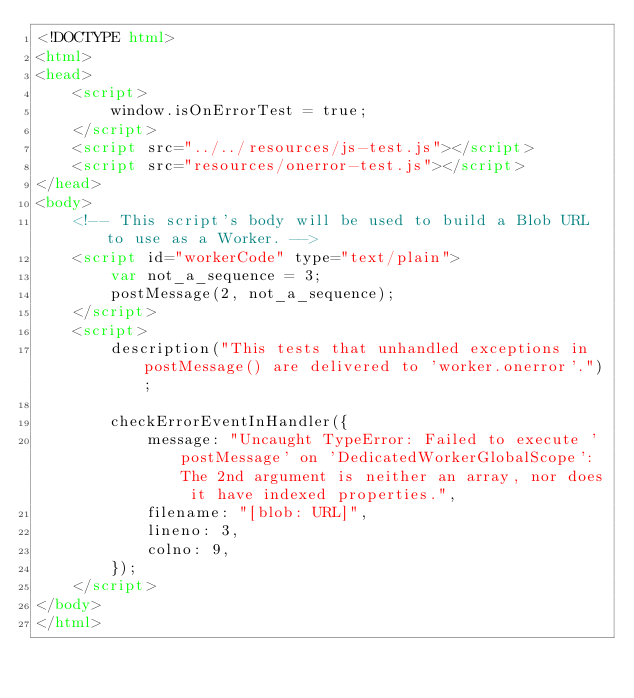Convert code to text. <code><loc_0><loc_0><loc_500><loc_500><_HTML_><!DOCTYPE html>
<html>
<head>
    <script>
        window.isOnErrorTest = true;
    </script>
    <script src="../../resources/js-test.js"></script>
    <script src="resources/onerror-test.js"></script>
</head>
<body>
    <!-- This script's body will be used to build a Blob URL to use as a Worker. -->
    <script id="workerCode" type="text/plain">
        var not_a_sequence = 3;
        postMessage(2, not_a_sequence);
    </script>
    <script>
        description("This tests that unhandled exceptions in postMessage() are delivered to 'worker.onerror'.");

        checkErrorEventInHandler({
            message: "Uncaught TypeError: Failed to execute 'postMessage' on 'DedicatedWorkerGlobalScope': The 2nd argument is neither an array, nor does it have indexed properties.",
            filename: "[blob: URL]",
            lineno: 3,
            colno: 9,
        });
    </script>
</body>
</html>
</code> 